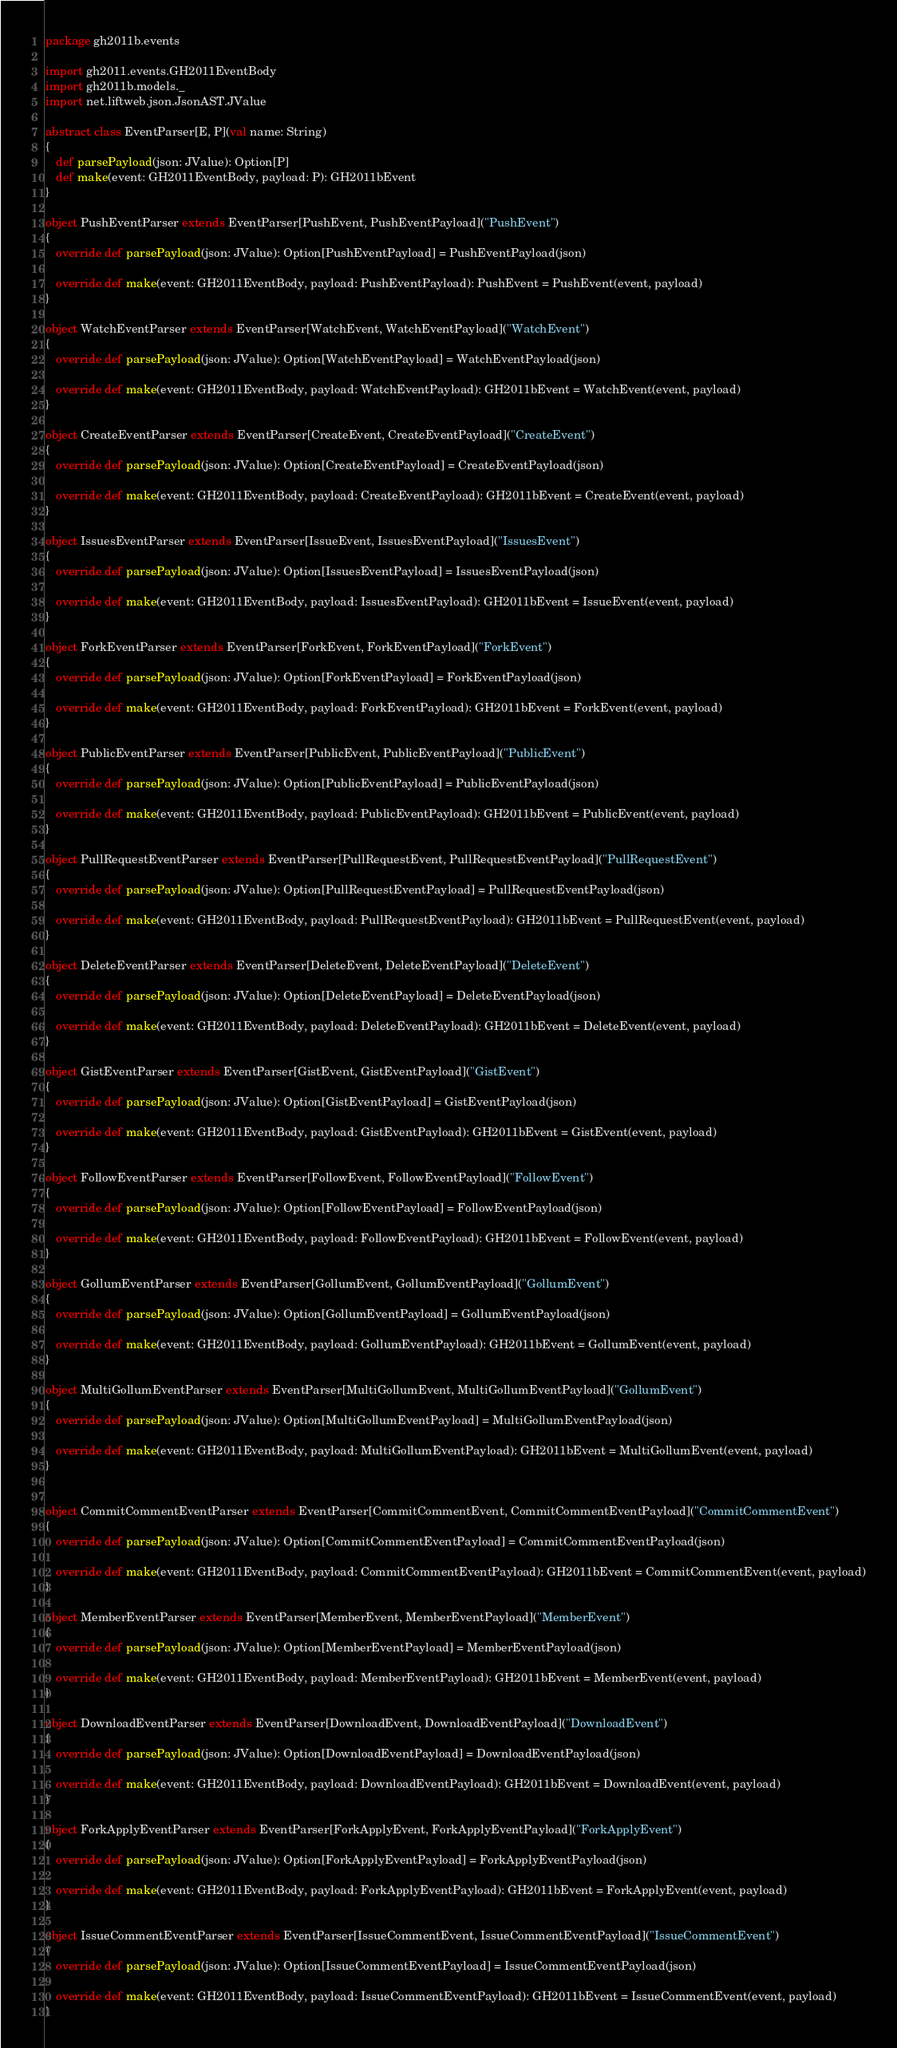Convert code to text. <code><loc_0><loc_0><loc_500><loc_500><_Scala_>package gh2011b.events

import gh2011.events.GH2011EventBody
import gh2011b.models._
import net.liftweb.json.JsonAST.JValue

abstract class EventParser[E, P](val name: String)
{
   def parsePayload(json: JValue): Option[P]
   def make(event: GH2011EventBody, payload: P): GH2011bEvent
}

object PushEventParser extends EventParser[PushEvent, PushEventPayload]("PushEvent")
{
   override def parsePayload(json: JValue): Option[PushEventPayload] = PushEventPayload(json)

   override def make(event: GH2011EventBody, payload: PushEventPayload): PushEvent = PushEvent(event, payload)
}

object WatchEventParser extends EventParser[WatchEvent, WatchEventPayload]("WatchEvent")
{
   override def parsePayload(json: JValue): Option[WatchEventPayload] = WatchEventPayload(json)

   override def make(event: GH2011EventBody, payload: WatchEventPayload): GH2011bEvent = WatchEvent(event, payload)
}

object CreateEventParser extends EventParser[CreateEvent, CreateEventPayload]("CreateEvent")
{
   override def parsePayload(json: JValue): Option[CreateEventPayload] = CreateEventPayload(json)

   override def make(event: GH2011EventBody, payload: CreateEventPayload): GH2011bEvent = CreateEvent(event, payload)
}

object IssuesEventParser extends EventParser[IssueEvent, IssuesEventPayload]("IssuesEvent")
{
   override def parsePayload(json: JValue): Option[IssuesEventPayload] = IssuesEventPayload(json)

   override def make(event: GH2011EventBody, payload: IssuesEventPayload): GH2011bEvent = IssueEvent(event, payload)
}

object ForkEventParser extends EventParser[ForkEvent, ForkEventPayload]("ForkEvent")
{
   override def parsePayload(json: JValue): Option[ForkEventPayload] = ForkEventPayload(json)

   override def make(event: GH2011EventBody, payload: ForkEventPayload): GH2011bEvent = ForkEvent(event, payload)
}

object PublicEventParser extends EventParser[PublicEvent, PublicEventPayload]("PublicEvent")
{
   override def parsePayload(json: JValue): Option[PublicEventPayload] = PublicEventPayload(json)

   override def make(event: GH2011EventBody, payload: PublicEventPayload): GH2011bEvent = PublicEvent(event, payload)
}

object PullRequestEventParser extends EventParser[PullRequestEvent, PullRequestEventPayload]("PullRequestEvent")
{
   override def parsePayload(json: JValue): Option[PullRequestEventPayload] = PullRequestEventPayload(json)

   override def make(event: GH2011EventBody, payload: PullRequestEventPayload): GH2011bEvent = PullRequestEvent(event, payload)
}

object DeleteEventParser extends EventParser[DeleteEvent, DeleteEventPayload]("DeleteEvent")
{
   override def parsePayload(json: JValue): Option[DeleteEventPayload] = DeleteEventPayload(json)

   override def make(event: GH2011EventBody, payload: DeleteEventPayload): GH2011bEvent = DeleteEvent(event, payload)
}

object GistEventParser extends EventParser[GistEvent, GistEventPayload]("GistEvent")
{
   override def parsePayload(json: JValue): Option[GistEventPayload] = GistEventPayload(json)

   override def make(event: GH2011EventBody, payload: GistEventPayload): GH2011bEvent = GistEvent(event, payload)
}

object FollowEventParser extends EventParser[FollowEvent, FollowEventPayload]("FollowEvent")
{
   override def parsePayload(json: JValue): Option[FollowEventPayload] = FollowEventPayload(json)

   override def make(event: GH2011EventBody, payload: FollowEventPayload): GH2011bEvent = FollowEvent(event, payload)
}

object GollumEventParser extends EventParser[GollumEvent, GollumEventPayload]("GollumEvent")
{
   override def parsePayload(json: JValue): Option[GollumEventPayload] = GollumEventPayload(json)

   override def make(event: GH2011EventBody, payload: GollumEventPayload): GH2011bEvent = GollumEvent(event, payload)
}

object MultiGollumEventParser extends EventParser[MultiGollumEvent, MultiGollumEventPayload]("GollumEvent")
{
   override def parsePayload(json: JValue): Option[MultiGollumEventPayload] = MultiGollumEventPayload(json)

   override def make(event: GH2011EventBody, payload: MultiGollumEventPayload): GH2011bEvent = MultiGollumEvent(event, payload)
}


object CommitCommentEventParser extends EventParser[CommitCommentEvent, CommitCommentEventPayload]("CommitCommentEvent")
{
   override def parsePayload(json: JValue): Option[CommitCommentEventPayload] = CommitCommentEventPayload(json)

   override def make(event: GH2011EventBody, payload: CommitCommentEventPayload): GH2011bEvent = CommitCommentEvent(event, payload)
}

object MemberEventParser extends EventParser[MemberEvent, MemberEventPayload]("MemberEvent")
{
   override def parsePayload(json: JValue): Option[MemberEventPayload] = MemberEventPayload(json)

   override def make(event: GH2011EventBody, payload: MemberEventPayload): GH2011bEvent = MemberEvent(event, payload)
}

object DownloadEventParser extends EventParser[DownloadEvent, DownloadEventPayload]("DownloadEvent")
{
   override def parsePayload(json: JValue): Option[DownloadEventPayload] = DownloadEventPayload(json)

   override def make(event: GH2011EventBody, payload: DownloadEventPayload): GH2011bEvent = DownloadEvent(event, payload)
}

object ForkApplyEventParser extends EventParser[ForkApplyEvent, ForkApplyEventPayload]("ForkApplyEvent")
{
   override def parsePayload(json: JValue): Option[ForkApplyEventPayload] = ForkApplyEventPayload(json)

   override def make(event: GH2011EventBody, payload: ForkApplyEventPayload): GH2011bEvent = ForkApplyEvent(event, payload)
}

object IssueCommentEventParser extends EventParser[IssueCommentEvent, IssueCommentEventPayload]("IssueCommentEvent")
{
   override def parsePayload(json: JValue): Option[IssueCommentEventPayload] = IssueCommentEventPayload(json)

   override def make(event: GH2011EventBody, payload: IssueCommentEventPayload): GH2011bEvent = IssueCommentEvent(event, payload)
}


</code> 